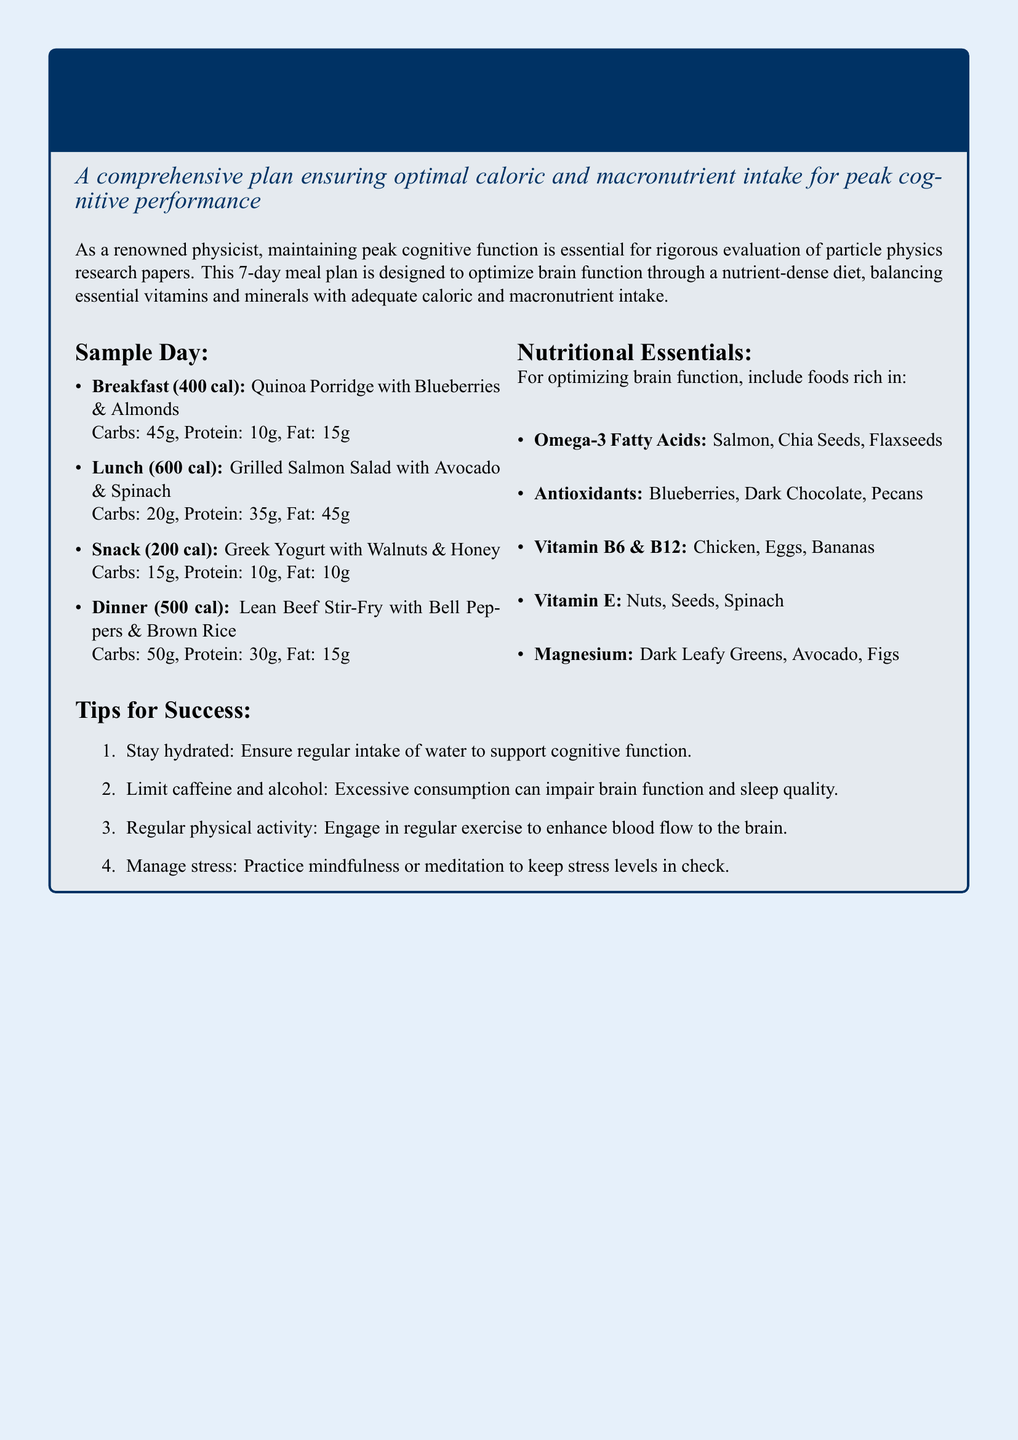What is the total caloric intake for the sample day? The total caloric intake is the sum of all meals: 400 cal + 600 cal + 200 cal + 500 cal = 1700 cal.
Answer: 1700 cal Which food item is listed as a breakfast option? The breakfast option listed is Quinoa Porridge with Blueberries & Almonds.
Answer: Quinoa Porridge with Blueberries & Almonds What is the primary source of Omega-3 fatty acids mentioned? The document mentions Salmon as a primary source of Omega-3 fatty acids.
Answer: Salmon How many grams of protein are in the lunch meal? The lunch meal, Grilled Salmon Salad with Avocado & Spinach, contains 35g of protein.
Answer: 35g What nutrient is specifically associated with Blueberries? Blueberries are specifically associated with antioxidants.
Answer: Antioxidants What is the recommendation concerning caffeine in the tips for success? The document advises to limit caffeine consumption.
Answer: Limit caffeine How many tips for success are provided in the document? The document provides a total of four tips for success.
Answer: Four Which vitamin is emphasized for brain function and is found in Chicken? Vitamin B6 & B12 is emphasized and found in Chicken.
Answer: Vitamin B6 & B12 